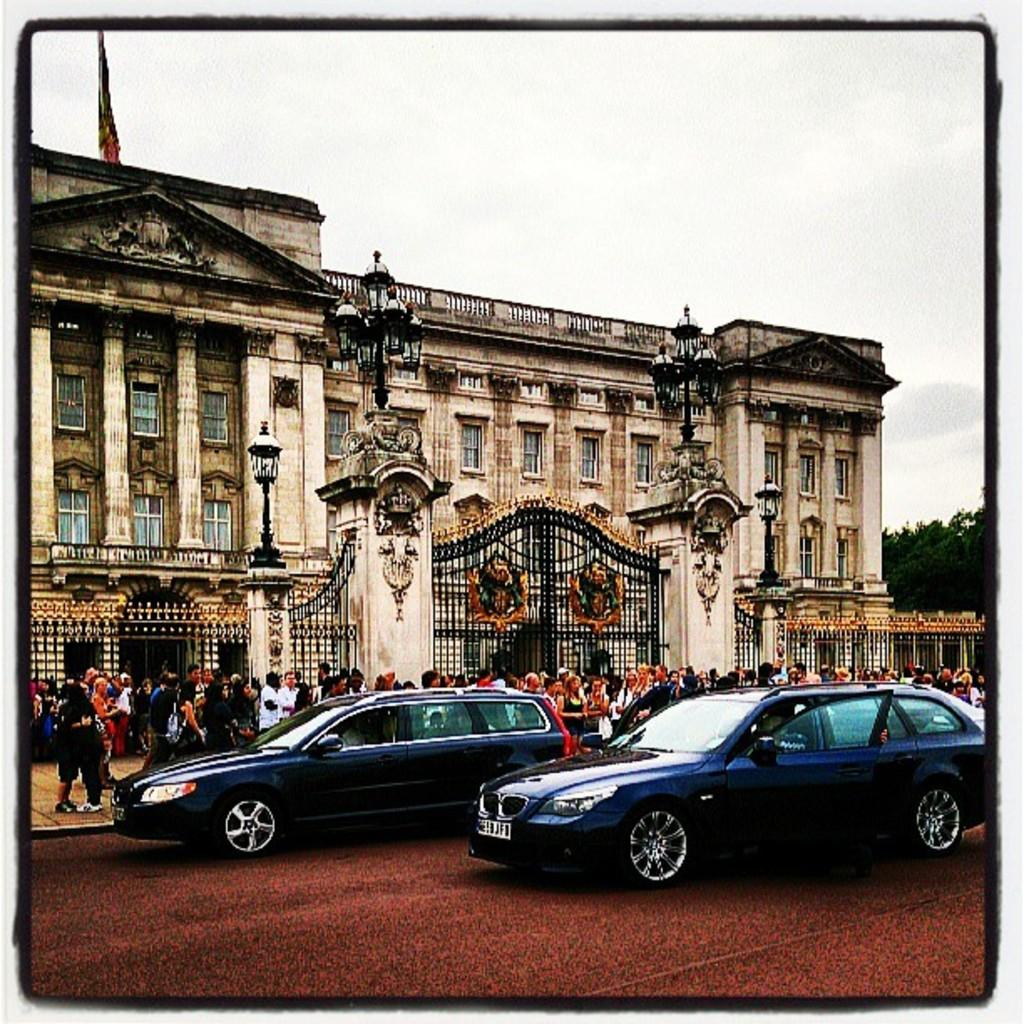What type of vehicles are on the road at the bottom of the image? There are two cars on the road at the bottom of the image. What are the people doing in the middle of the image? There are people walking on the footpath in the middle of the image. What is the main structure in the image? It is a monument in the image. What is the weather condition in the image? The sky is cloudy at the top of the image. Where is the rod used for fishing in the image? There is no rod used for fishing present in the image. What type of badge is being awarded to the person in the image? There is no person receiving a badge in the image. 